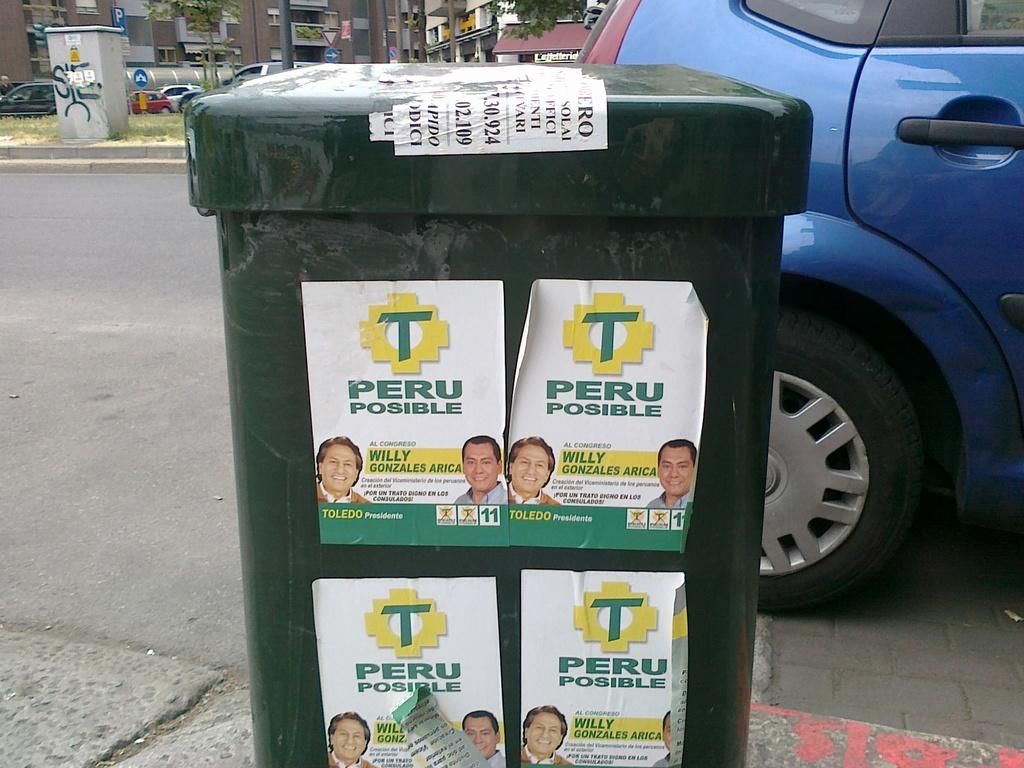<image>
Write a terse but informative summary of the picture. Four signs on display that say Peru Posible. 